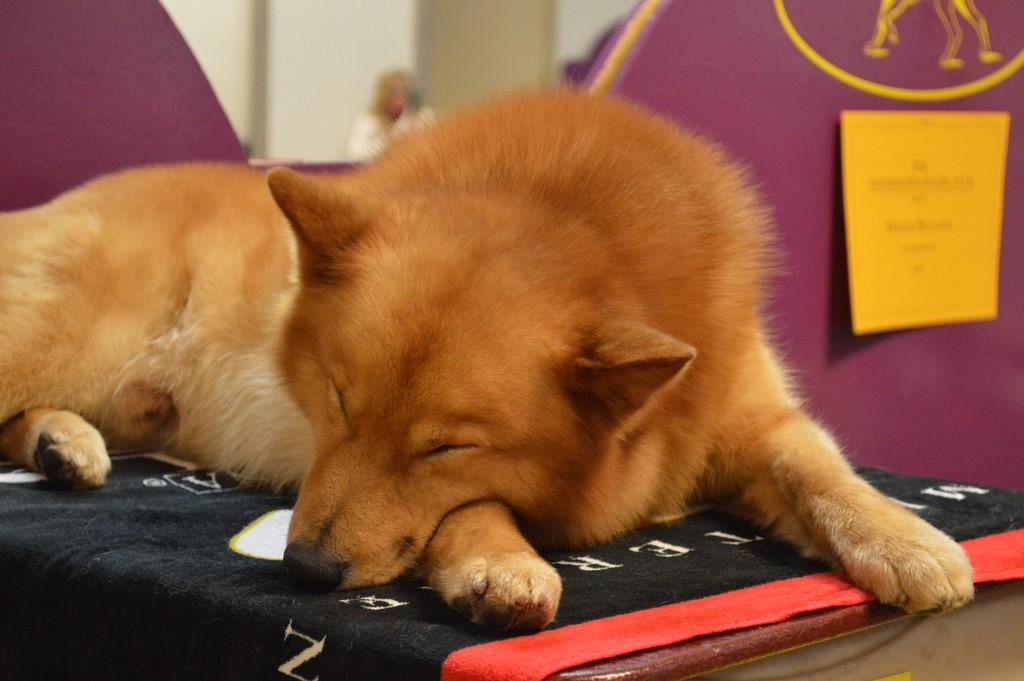What animal is present in the image? There is a dog in the image. Where is the dog located in the image? The dog is placed on a table. What type of whip can be seen    in the image? There is no whip present in the image; it only features a dog on a table. 